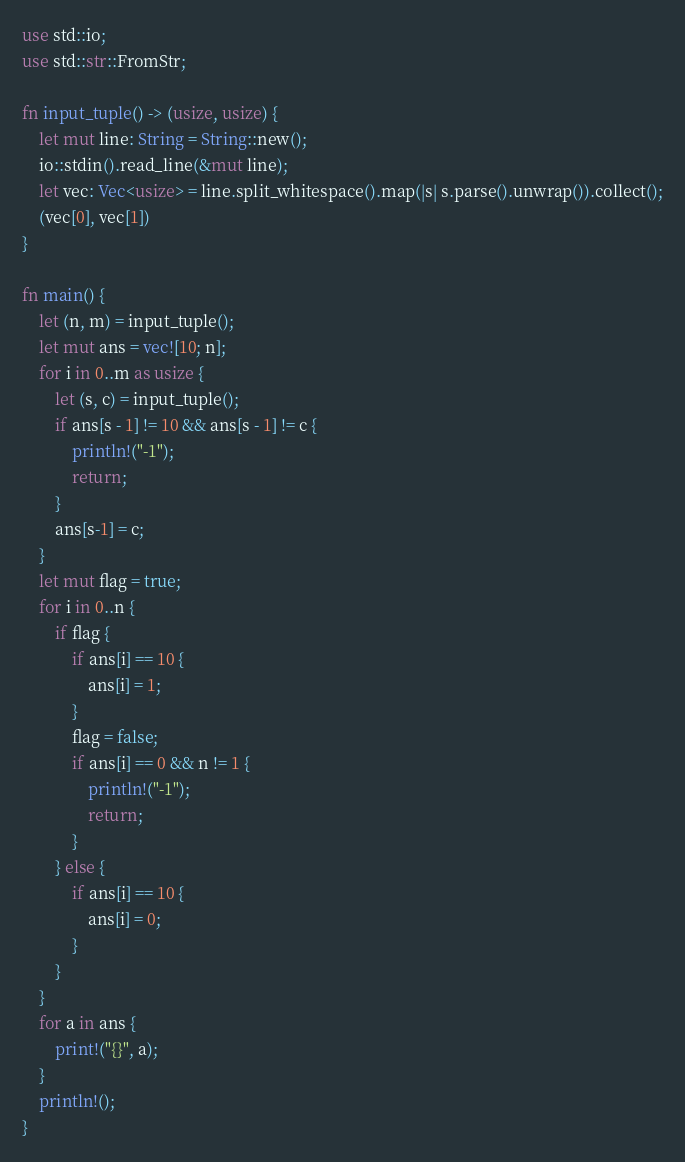<code> <loc_0><loc_0><loc_500><loc_500><_Rust_>use std::io;
use std::str::FromStr;

fn input_tuple() -> (usize, usize) {
    let mut line: String = String::new();
    io::stdin().read_line(&mut line);
    let vec: Vec<usize> = line.split_whitespace().map(|s| s.parse().unwrap()).collect();
    (vec[0], vec[1])
}

fn main() {
    let (n, m) = input_tuple();
    let mut ans = vec![10; n];
    for i in 0..m as usize {
        let (s, c) = input_tuple();
        if ans[s - 1] != 10 && ans[s - 1] != c {
            println!("-1");
            return;
        }
        ans[s-1] = c;
    }
    let mut flag = true;
    for i in 0..n {
        if flag {
            if ans[i] == 10 {
                ans[i] = 1;
            }
            flag = false;
            if ans[i] == 0 && n != 1 {
                println!("-1");
                return;
            }
        } else {
            if ans[i] == 10 {
                ans[i] = 0;
            }
        }
    }
    for a in ans {
        print!("{}", a);
    }
    println!();
}
</code> 